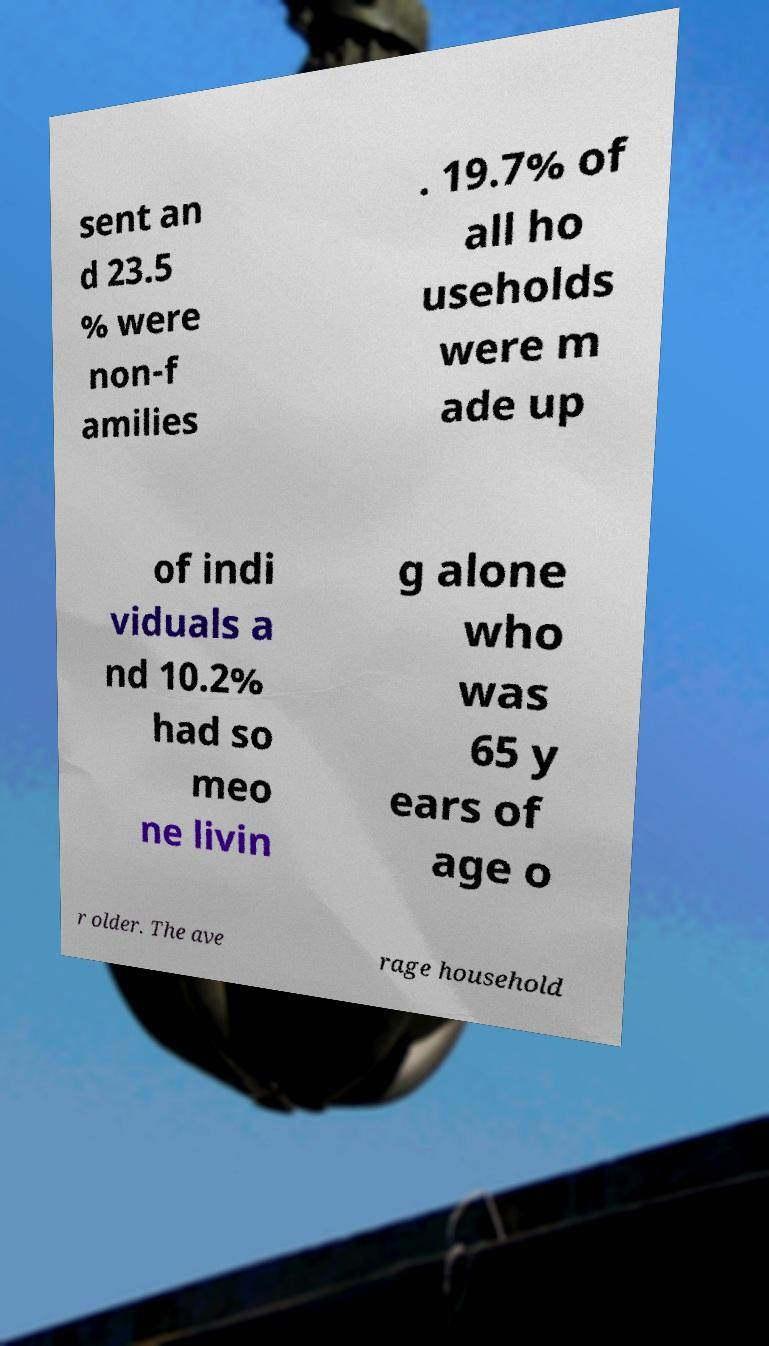Please identify and transcribe the text found in this image. sent an d 23.5 % were non-f amilies . 19.7% of all ho useholds were m ade up of indi viduals a nd 10.2% had so meo ne livin g alone who was 65 y ears of age o r older. The ave rage household 